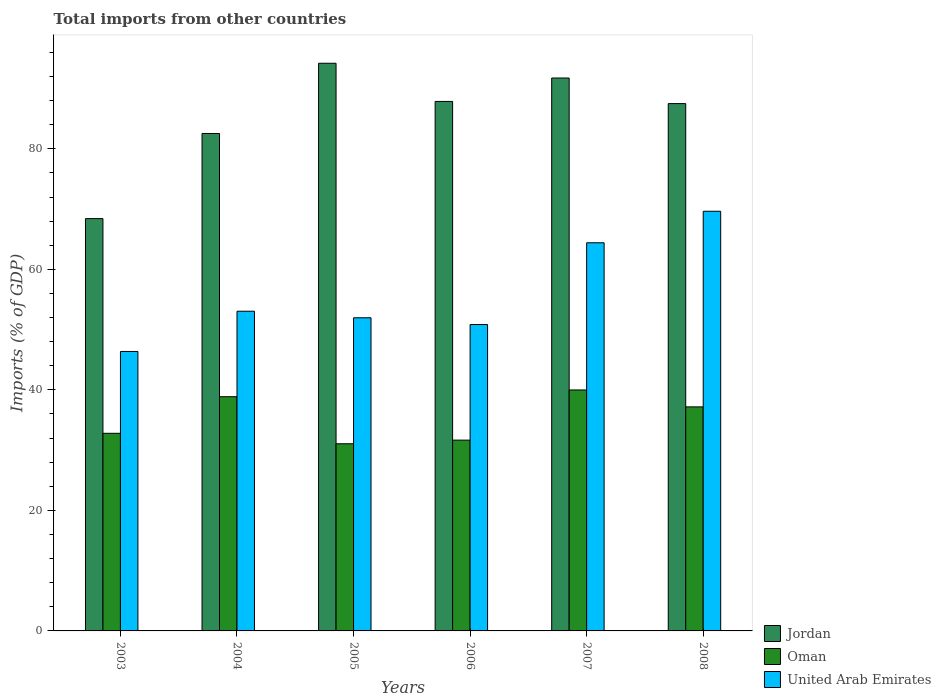How many different coloured bars are there?
Your response must be concise. 3. How many groups of bars are there?
Your answer should be compact. 6. What is the label of the 1st group of bars from the left?
Your answer should be compact. 2003. What is the total imports in Jordan in 2007?
Your answer should be compact. 91.76. Across all years, what is the maximum total imports in United Arab Emirates?
Offer a very short reply. 69.65. Across all years, what is the minimum total imports in Oman?
Provide a short and direct response. 31.06. In which year was the total imports in Jordan maximum?
Make the answer very short. 2005. What is the total total imports in Jordan in the graph?
Your answer should be compact. 512.33. What is the difference between the total imports in Oman in 2003 and that in 2007?
Offer a terse response. -7.19. What is the difference between the total imports in Jordan in 2007 and the total imports in United Arab Emirates in 2008?
Your answer should be very brief. 22.11. What is the average total imports in United Arab Emirates per year?
Provide a succinct answer. 56.05. In the year 2006, what is the difference between the total imports in Oman and total imports in Jordan?
Your answer should be very brief. -56.21. In how many years, is the total imports in United Arab Emirates greater than 16 %?
Provide a succinct answer. 6. What is the ratio of the total imports in United Arab Emirates in 2003 to that in 2006?
Keep it short and to the point. 0.91. Is the total imports in Jordan in 2006 less than that in 2007?
Give a very brief answer. Yes. What is the difference between the highest and the second highest total imports in Jordan?
Your answer should be very brief. 2.45. What is the difference between the highest and the lowest total imports in United Arab Emirates?
Your response must be concise. 23.27. In how many years, is the total imports in United Arab Emirates greater than the average total imports in United Arab Emirates taken over all years?
Your answer should be very brief. 2. Is the sum of the total imports in Oman in 2004 and 2005 greater than the maximum total imports in Jordan across all years?
Provide a short and direct response. No. What does the 2nd bar from the left in 2006 represents?
Make the answer very short. Oman. What does the 2nd bar from the right in 2006 represents?
Make the answer very short. Oman. Is it the case that in every year, the sum of the total imports in Jordan and total imports in Oman is greater than the total imports in United Arab Emirates?
Your answer should be very brief. Yes. How many bars are there?
Provide a short and direct response. 18. Are all the bars in the graph horizontal?
Your response must be concise. No. Are the values on the major ticks of Y-axis written in scientific E-notation?
Provide a short and direct response. No. Where does the legend appear in the graph?
Keep it short and to the point. Bottom right. How many legend labels are there?
Provide a short and direct response. 3. How are the legend labels stacked?
Offer a very short reply. Vertical. What is the title of the graph?
Your response must be concise. Total imports from other countries. What is the label or title of the X-axis?
Give a very brief answer. Years. What is the label or title of the Y-axis?
Your answer should be very brief. Imports (% of GDP). What is the Imports (% of GDP) in Jordan in 2003?
Your answer should be compact. 68.43. What is the Imports (% of GDP) of Oman in 2003?
Offer a terse response. 32.8. What is the Imports (% of GDP) in United Arab Emirates in 2003?
Offer a terse response. 46.38. What is the Imports (% of GDP) in Jordan in 2004?
Ensure brevity in your answer.  82.55. What is the Imports (% of GDP) of Oman in 2004?
Your answer should be very brief. 38.87. What is the Imports (% of GDP) in United Arab Emirates in 2004?
Your answer should be very brief. 53.05. What is the Imports (% of GDP) of Jordan in 2005?
Make the answer very short. 94.21. What is the Imports (% of GDP) of Oman in 2005?
Provide a short and direct response. 31.06. What is the Imports (% of GDP) of United Arab Emirates in 2005?
Offer a terse response. 51.97. What is the Imports (% of GDP) in Jordan in 2006?
Offer a terse response. 87.87. What is the Imports (% of GDP) of Oman in 2006?
Your answer should be very brief. 31.66. What is the Imports (% of GDP) of United Arab Emirates in 2006?
Offer a terse response. 50.85. What is the Imports (% of GDP) in Jordan in 2007?
Your response must be concise. 91.76. What is the Imports (% of GDP) in Oman in 2007?
Keep it short and to the point. 39.99. What is the Imports (% of GDP) of United Arab Emirates in 2007?
Offer a terse response. 64.41. What is the Imports (% of GDP) in Jordan in 2008?
Make the answer very short. 87.51. What is the Imports (% of GDP) of Oman in 2008?
Offer a very short reply. 37.18. What is the Imports (% of GDP) of United Arab Emirates in 2008?
Ensure brevity in your answer.  69.65. Across all years, what is the maximum Imports (% of GDP) of Jordan?
Your answer should be very brief. 94.21. Across all years, what is the maximum Imports (% of GDP) of Oman?
Offer a very short reply. 39.99. Across all years, what is the maximum Imports (% of GDP) in United Arab Emirates?
Provide a succinct answer. 69.65. Across all years, what is the minimum Imports (% of GDP) of Jordan?
Keep it short and to the point. 68.43. Across all years, what is the minimum Imports (% of GDP) in Oman?
Provide a short and direct response. 31.06. Across all years, what is the minimum Imports (% of GDP) of United Arab Emirates?
Ensure brevity in your answer.  46.38. What is the total Imports (% of GDP) in Jordan in the graph?
Your answer should be very brief. 512.33. What is the total Imports (% of GDP) of Oman in the graph?
Keep it short and to the point. 211.56. What is the total Imports (% of GDP) of United Arab Emirates in the graph?
Give a very brief answer. 336.3. What is the difference between the Imports (% of GDP) in Jordan in 2003 and that in 2004?
Make the answer very short. -14.13. What is the difference between the Imports (% of GDP) in Oman in 2003 and that in 2004?
Provide a succinct answer. -6.07. What is the difference between the Imports (% of GDP) in United Arab Emirates in 2003 and that in 2004?
Ensure brevity in your answer.  -6.68. What is the difference between the Imports (% of GDP) in Jordan in 2003 and that in 2005?
Your response must be concise. -25.78. What is the difference between the Imports (% of GDP) of Oman in 2003 and that in 2005?
Your response must be concise. 1.74. What is the difference between the Imports (% of GDP) of United Arab Emirates in 2003 and that in 2005?
Give a very brief answer. -5.59. What is the difference between the Imports (% of GDP) of Jordan in 2003 and that in 2006?
Offer a terse response. -19.45. What is the difference between the Imports (% of GDP) in Oman in 2003 and that in 2006?
Keep it short and to the point. 1.13. What is the difference between the Imports (% of GDP) of United Arab Emirates in 2003 and that in 2006?
Make the answer very short. -4.47. What is the difference between the Imports (% of GDP) in Jordan in 2003 and that in 2007?
Keep it short and to the point. -23.33. What is the difference between the Imports (% of GDP) in Oman in 2003 and that in 2007?
Ensure brevity in your answer.  -7.19. What is the difference between the Imports (% of GDP) in United Arab Emirates in 2003 and that in 2007?
Ensure brevity in your answer.  -18.04. What is the difference between the Imports (% of GDP) in Jordan in 2003 and that in 2008?
Ensure brevity in your answer.  -19.09. What is the difference between the Imports (% of GDP) of Oman in 2003 and that in 2008?
Ensure brevity in your answer.  -4.39. What is the difference between the Imports (% of GDP) in United Arab Emirates in 2003 and that in 2008?
Provide a short and direct response. -23.27. What is the difference between the Imports (% of GDP) of Jordan in 2004 and that in 2005?
Your response must be concise. -11.65. What is the difference between the Imports (% of GDP) in Oman in 2004 and that in 2005?
Your answer should be compact. 7.81. What is the difference between the Imports (% of GDP) in United Arab Emirates in 2004 and that in 2005?
Your response must be concise. 1.09. What is the difference between the Imports (% of GDP) of Jordan in 2004 and that in 2006?
Your answer should be compact. -5.32. What is the difference between the Imports (% of GDP) of Oman in 2004 and that in 2006?
Provide a short and direct response. 7.21. What is the difference between the Imports (% of GDP) in United Arab Emirates in 2004 and that in 2006?
Offer a terse response. 2.21. What is the difference between the Imports (% of GDP) in Jordan in 2004 and that in 2007?
Your response must be concise. -9.21. What is the difference between the Imports (% of GDP) of Oman in 2004 and that in 2007?
Your answer should be compact. -1.12. What is the difference between the Imports (% of GDP) of United Arab Emirates in 2004 and that in 2007?
Provide a short and direct response. -11.36. What is the difference between the Imports (% of GDP) in Jordan in 2004 and that in 2008?
Your answer should be very brief. -4.96. What is the difference between the Imports (% of GDP) of Oman in 2004 and that in 2008?
Your answer should be very brief. 1.69. What is the difference between the Imports (% of GDP) of United Arab Emirates in 2004 and that in 2008?
Give a very brief answer. -16.59. What is the difference between the Imports (% of GDP) of Jordan in 2005 and that in 2006?
Keep it short and to the point. 6.33. What is the difference between the Imports (% of GDP) in Oman in 2005 and that in 2006?
Offer a terse response. -0.6. What is the difference between the Imports (% of GDP) in United Arab Emirates in 2005 and that in 2006?
Offer a very short reply. 1.12. What is the difference between the Imports (% of GDP) of Jordan in 2005 and that in 2007?
Provide a short and direct response. 2.45. What is the difference between the Imports (% of GDP) in Oman in 2005 and that in 2007?
Your answer should be compact. -8.93. What is the difference between the Imports (% of GDP) in United Arab Emirates in 2005 and that in 2007?
Keep it short and to the point. -12.45. What is the difference between the Imports (% of GDP) of Jordan in 2005 and that in 2008?
Ensure brevity in your answer.  6.7. What is the difference between the Imports (% of GDP) of Oman in 2005 and that in 2008?
Make the answer very short. -6.12. What is the difference between the Imports (% of GDP) in United Arab Emirates in 2005 and that in 2008?
Your answer should be very brief. -17.68. What is the difference between the Imports (% of GDP) in Jordan in 2006 and that in 2007?
Give a very brief answer. -3.89. What is the difference between the Imports (% of GDP) in Oman in 2006 and that in 2007?
Provide a short and direct response. -8.33. What is the difference between the Imports (% of GDP) of United Arab Emirates in 2006 and that in 2007?
Make the answer very short. -13.57. What is the difference between the Imports (% of GDP) of Jordan in 2006 and that in 2008?
Your answer should be compact. 0.36. What is the difference between the Imports (% of GDP) of Oman in 2006 and that in 2008?
Offer a very short reply. -5.52. What is the difference between the Imports (% of GDP) of United Arab Emirates in 2006 and that in 2008?
Provide a short and direct response. -18.8. What is the difference between the Imports (% of GDP) in Jordan in 2007 and that in 2008?
Make the answer very short. 4.25. What is the difference between the Imports (% of GDP) of Oman in 2007 and that in 2008?
Your answer should be compact. 2.81. What is the difference between the Imports (% of GDP) in United Arab Emirates in 2007 and that in 2008?
Your answer should be very brief. -5.23. What is the difference between the Imports (% of GDP) in Jordan in 2003 and the Imports (% of GDP) in Oman in 2004?
Provide a succinct answer. 29.56. What is the difference between the Imports (% of GDP) in Jordan in 2003 and the Imports (% of GDP) in United Arab Emirates in 2004?
Provide a short and direct response. 15.37. What is the difference between the Imports (% of GDP) in Oman in 2003 and the Imports (% of GDP) in United Arab Emirates in 2004?
Make the answer very short. -20.26. What is the difference between the Imports (% of GDP) in Jordan in 2003 and the Imports (% of GDP) in Oman in 2005?
Offer a very short reply. 37.37. What is the difference between the Imports (% of GDP) of Jordan in 2003 and the Imports (% of GDP) of United Arab Emirates in 2005?
Provide a succinct answer. 16.46. What is the difference between the Imports (% of GDP) of Oman in 2003 and the Imports (% of GDP) of United Arab Emirates in 2005?
Ensure brevity in your answer.  -19.17. What is the difference between the Imports (% of GDP) of Jordan in 2003 and the Imports (% of GDP) of Oman in 2006?
Ensure brevity in your answer.  36.76. What is the difference between the Imports (% of GDP) of Jordan in 2003 and the Imports (% of GDP) of United Arab Emirates in 2006?
Provide a short and direct response. 17.58. What is the difference between the Imports (% of GDP) in Oman in 2003 and the Imports (% of GDP) in United Arab Emirates in 2006?
Your answer should be compact. -18.05. What is the difference between the Imports (% of GDP) of Jordan in 2003 and the Imports (% of GDP) of Oman in 2007?
Provide a short and direct response. 28.44. What is the difference between the Imports (% of GDP) in Jordan in 2003 and the Imports (% of GDP) in United Arab Emirates in 2007?
Provide a short and direct response. 4.01. What is the difference between the Imports (% of GDP) of Oman in 2003 and the Imports (% of GDP) of United Arab Emirates in 2007?
Give a very brief answer. -31.62. What is the difference between the Imports (% of GDP) in Jordan in 2003 and the Imports (% of GDP) in Oman in 2008?
Provide a succinct answer. 31.25. What is the difference between the Imports (% of GDP) of Jordan in 2003 and the Imports (% of GDP) of United Arab Emirates in 2008?
Make the answer very short. -1.22. What is the difference between the Imports (% of GDP) of Oman in 2003 and the Imports (% of GDP) of United Arab Emirates in 2008?
Make the answer very short. -36.85. What is the difference between the Imports (% of GDP) in Jordan in 2004 and the Imports (% of GDP) in Oman in 2005?
Give a very brief answer. 51.49. What is the difference between the Imports (% of GDP) of Jordan in 2004 and the Imports (% of GDP) of United Arab Emirates in 2005?
Provide a short and direct response. 30.59. What is the difference between the Imports (% of GDP) in Oman in 2004 and the Imports (% of GDP) in United Arab Emirates in 2005?
Make the answer very short. -13.1. What is the difference between the Imports (% of GDP) in Jordan in 2004 and the Imports (% of GDP) in Oman in 2006?
Provide a short and direct response. 50.89. What is the difference between the Imports (% of GDP) of Jordan in 2004 and the Imports (% of GDP) of United Arab Emirates in 2006?
Keep it short and to the point. 31.71. What is the difference between the Imports (% of GDP) in Oman in 2004 and the Imports (% of GDP) in United Arab Emirates in 2006?
Provide a short and direct response. -11.98. What is the difference between the Imports (% of GDP) in Jordan in 2004 and the Imports (% of GDP) in Oman in 2007?
Give a very brief answer. 42.56. What is the difference between the Imports (% of GDP) of Jordan in 2004 and the Imports (% of GDP) of United Arab Emirates in 2007?
Offer a very short reply. 18.14. What is the difference between the Imports (% of GDP) of Oman in 2004 and the Imports (% of GDP) of United Arab Emirates in 2007?
Give a very brief answer. -25.54. What is the difference between the Imports (% of GDP) of Jordan in 2004 and the Imports (% of GDP) of Oman in 2008?
Your answer should be compact. 45.37. What is the difference between the Imports (% of GDP) in Jordan in 2004 and the Imports (% of GDP) in United Arab Emirates in 2008?
Ensure brevity in your answer.  12.91. What is the difference between the Imports (% of GDP) in Oman in 2004 and the Imports (% of GDP) in United Arab Emirates in 2008?
Ensure brevity in your answer.  -30.78. What is the difference between the Imports (% of GDP) in Jordan in 2005 and the Imports (% of GDP) in Oman in 2006?
Offer a very short reply. 62.54. What is the difference between the Imports (% of GDP) of Jordan in 2005 and the Imports (% of GDP) of United Arab Emirates in 2006?
Offer a very short reply. 43.36. What is the difference between the Imports (% of GDP) of Oman in 2005 and the Imports (% of GDP) of United Arab Emirates in 2006?
Provide a short and direct response. -19.79. What is the difference between the Imports (% of GDP) of Jordan in 2005 and the Imports (% of GDP) of Oman in 2007?
Keep it short and to the point. 54.22. What is the difference between the Imports (% of GDP) in Jordan in 2005 and the Imports (% of GDP) in United Arab Emirates in 2007?
Give a very brief answer. 29.79. What is the difference between the Imports (% of GDP) in Oman in 2005 and the Imports (% of GDP) in United Arab Emirates in 2007?
Your answer should be very brief. -33.35. What is the difference between the Imports (% of GDP) of Jordan in 2005 and the Imports (% of GDP) of Oman in 2008?
Offer a terse response. 57.03. What is the difference between the Imports (% of GDP) of Jordan in 2005 and the Imports (% of GDP) of United Arab Emirates in 2008?
Give a very brief answer. 24.56. What is the difference between the Imports (% of GDP) of Oman in 2005 and the Imports (% of GDP) of United Arab Emirates in 2008?
Your answer should be very brief. -38.59. What is the difference between the Imports (% of GDP) in Jordan in 2006 and the Imports (% of GDP) in Oman in 2007?
Your answer should be compact. 47.88. What is the difference between the Imports (% of GDP) of Jordan in 2006 and the Imports (% of GDP) of United Arab Emirates in 2007?
Your response must be concise. 23.46. What is the difference between the Imports (% of GDP) of Oman in 2006 and the Imports (% of GDP) of United Arab Emirates in 2007?
Keep it short and to the point. -32.75. What is the difference between the Imports (% of GDP) of Jordan in 2006 and the Imports (% of GDP) of Oman in 2008?
Ensure brevity in your answer.  50.69. What is the difference between the Imports (% of GDP) in Jordan in 2006 and the Imports (% of GDP) in United Arab Emirates in 2008?
Your answer should be compact. 18.23. What is the difference between the Imports (% of GDP) in Oman in 2006 and the Imports (% of GDP) in United Arab Emirates in 2008?
Your answer should be compact. -37.98. What is the difference between the Imports (% of GDP) of Jordan in 2007 and the Imports (% of GDP) of Oman in 2008?
Provide a succinct answer. 54.58. What is the difference between the Imports (% of GDP) in Jordan in 2007 and the Imports (% of GDP) in United Arab Emirates in 2008?
Provide a short and direct response. 22.11. What is the difference between the Imports (% of GDP) in Oman in 2007 and the Imports (% of GDP) in United Arab Emirates in 2008?
Offer a terse response. -29.66. What is the average Imports (% of GDP) in Jordan per year?
Your response must be concise. 85.39. What is the average Imports (% of GDP) in Oman per year?
Make the answer very short. 35.26. What is the average Imports (% of GDP) of United Arab Emirates per year?
Make the answer very short. 56.05. In the year 2003, what is the difference between the Imports (% of GDP) of Jordan and Imports (% of GDP) of Oman?
Your response must be concise. 35.63. In the year 2003, what is the difference between the Imports (% of GDP) of Jordan and Imports (% of GDP) of United Arab Emirates?
Keep it short and to the point. 22.05. In the year 2003, what is the difference between the Imports (% of GDP) in Oman and Imports (% of GDP) in United Arab Emirates?
Offer a terse response. -13.58. In the year 2004, what is the difference between the Imports (% of GDP) in Jordan and Imports (% of GDP) in Oman?
Make the answer very short. 43.68. In the year 2004, what is the difference between the Imports (% of GDP) of Jordan and Imports (% of GDP) of United Arab Emirates?
Make the answer very short. 29.5. In the year 2004, what is the difference between the Imports (% of GDP) in Oman and Imports (% of GDP) in United Arab Emirates?
Offer a very short reply. -14.19. In the year 2005, what is the difference between the Imports (% of GDP) in Jordan and Imports (% of GDP) in Oman?
Offer a terse response. 63.15. In the year 2005, what is the difference between the Imports (% of GDP) of Jordan and Imports (% of GDP) of United Arab Emirates?
Your response must be concise. 42.24. In the year 2005, what is the difference between the Imports (% of GDP) of Oman and Imports (% of GDP) of United Arab Emirates?
Offer a terse response. -20.91. In the year 2006, what is the difference between the Imports (% of GDP) in Jordan and Imports (% of GDP) in Oman?
Provide a succinct answer. 56.21. In the year 2006, what is the difference between the Imports (% of GDP) in Jordan and Imports (% of GDP) in United Arab Emirates?
Your answer should be compact. 37.03. In the year 2006, what is the difference between the Imports (% of GDP) in Oman and Imports (% of GDP) in United Arab Emirates?
Offer a terse response. -19.18. In the year 2007, what is the difference between the Imports (% of GDP) of Jordan and Imports (% of GDP) of Oman?
Make the answer very short. 51.77. In the year 2007, what is the difference between the Imports (% of GDP) of Jordan and Imports (% of GDP) of United Arab Emirates?
Ensure brevity in your answer.  27.34. In the year 2007, what is the difference between the Imports (% of GDP) in Oman and Imports (% of GDP) in United Arab Emirates?
Offer a very short reply. -24.42. In the year 2008, what is the difference between the Imports (% of GDP) in Jordan and Imports (% of GDP) in Oman?
Offer a terse response. 50.33. In the year 2008, what is the difference between the Imports (% of GDP) in Jordan and Imports (% of GDP) in United Arab Emirates?
Ensure brevity in your answer.  17.87. In the year 2008, what is the difference between the Imports (% of GDP) of Oman and Imports (% of GDP) of United Arab Emirates?
Your response must be concise. -32.47. What is the ratio of the Imports (% of GDP) in Jordan in 2003 to that in 2004?
Ensure brevity in your answer.  0.83. What is the ratio of the Imports (% of GDP) in Oman in 2003 to that in 2004?
Keep it short and to the point. 0.84. What is the ratio of the Imports (% of GDP) in United Arab Emirates in 2003 to that in 2004?
Give a very brief answer. 0.87. What is the ratio of the Imports (% of GDP) in Jordan in 2003 to that in 2005?
Offer a terse response. 0.73. What is the ratio of the Imports (% of GDP) in Oman in 2003 to that in 2005?
Your answer should be very brief. 1.06. What is the ratio of the Imports (% of GDP) in United Arab Emirates in 2003 to that in 2005?
Give a very brief answer. 0.89. What is the ratio of the Imports (% of GDP) of Jordan in 2003 to that in 2006?
Keep it short and to the point. 0.78. What is the ratio of the Imports (% of GDP) of Oman in 2003 to that in 2006?
Keep it short and to the point. 1.04. What is the ratio of the Imports (% of GDP) of United Arab Emirates in 2003 to that in 2006?
Offer a terse response. 0.91. What is the ratio of the Imports (% of GDP) in Jordan in 2003 to that in 2007?
Your answer should be very brief. 0.75. What is the ratio of the Imports (% of GDP) of Oman in 2003 to that in 2007?
Ensure brevity in your answer.  0.82. What is the ratio of the Imports (% of GDP) in United Arab Emirates in 2003 to that in 2007?
Give a very brief answer. 0.72. What is the ratio of the Imports (% of GDP) of Jordan in 2003 to that in 2008?
Your answer should be very brief. 0.78. What is the ratio of the Imports (% of GDP) of Oman in 2003 to that in 2008?
Provide a succinct answer. 0.88. What is the ratio of the Imports (% of GDP) of United Arab Emirates in 2003 to that in 2008?
Offer a very short reply. 0.67. What is the ratio of the Imports (% of GDP) of Jordan in 2004 to that in 2005?
Your answer should be compact. 0.88. What is the ratio of the Imports (% of GDP) in Oman in 2004 to that in 2005?
Make the answer very short. 1.25. What is the ratio of the Imports (% of GDP) in United Arab Emirates in 2004 to that in 2005?
Offer a very short reply. 1.02. What is the ratio of the Imports (% of GDP) in Jordan in 2004 to that in 2006?
Ensure brevity in your answer.  0.94. What is the ratio of the Imports (% of GDP) of Oman in 2004 to that in 2006?
Provide a short and direct response. 1.23. What is the ratio of the Imports (% of GDP) in United Arab Emirates in 2004 to that in 2006?
Keep it short and to the point. 1.04. What is the ratio of the Imports (% of GDP) in Jordan in 2004 to that in 2007?
Ensure brevity in your answer.  0.9. What is the ratio of the Imports (% of GDP) of United Arab Emirates in 2004 to that in 2007?
Offer a terse response. 0.82. What is the ratio of the Imports (% of GDP) in Jordan in 2004 to that in 2008?
Your response must be concise. 0.94. What is the ratio of the Imports (% of GDP) in Oman in 2004 to that in 2008?
Your response must be concise. 1.05. What is the ratio of the Imports (% of GDP) in United Arab Emirates in 2004 to that in 2008?
Your answer should be compact. 0.76. What is the ratio of the Imports (% of GDP) in Jordan in 2005 to that in 2006?
Offer a very short reply. 1.07. What is the ratio of the Imports (% of GDP) of Oman in 2005 to that in 2006?
Your answer should be very brief. 0.98. What is the ratio of the Imports (% of GDP) in United Arab Emirates in 2005 to that in 2006?
Offer a terse response. 1.02. What is the ratio of the Imports (% of GDP) in Jordan in 2005 to that in 2007?
Your response must be concise. 1.03. What is the ratio of the Imports (% of GDP) of Oman in 2005 to that in 2007?
Offer a terse response. 0.78. What is the ratio of the Imports (% of GDP) in United Arab Emirates in 2005 to that in 2007?
Your response must be concise. 0.81. What is the ratio of the Imports (% of GDP) in Jordan in 2005 to that in 2008?
Offer a terse response. 1.08. What is the ratio of the Imports (% of GDP) of Oman in 2005 to that in 2008?
Make the answer very short. 0.84. What is the ratio of the Imports (% of GDP) in United Arab Emirates in 2005 to that in 2008?
Offer a very short reply. 0.75. What is the ratio of the Imports (% of GDP) of Jordan in 2006 to that in 2007?
Your answer should be compact. 0.96. What is the ratio of the Imports (% of GDP) of Oman in 2006 to that in 2007?
Ensure brevity in your answer.  0.79. What is the ratio of the Imports (% of GDP) in United Arab Emirates in 2006 to that in 2007?
Keep it short and to the point. 0.79. What is the ratio of the Imports (% of GDP) in Jordan in 2006 to that in 2008?
Give a very brief answer. 1. What is the ratio of the Imports (% of GDP) of Oman in 2006 to that in 2008?
Offer a terse response. 0.85. What is the ratio of the Imports (% of GDP) of United Arab Emirates in 2006 to that in 2008?
Your answer should be very brief. 0.73. What is the ratio of the Imports (% of GDP) of Jordan in 2007 to that in 2008?
Your answer should be very brief. 1.05. What is the ratio of the Imports (% of GDP) in Oman in 2007 to that in 2008?
Give a very brief answer. 1.08. What is the ratio of the Imports (% of GDP) of United Arab Emirates in 2007 to that in 2008?
Give a very brief answer. 0.92. What is the difference between the highest and the second highest Imports (% of GDP) in Jordan?
Give a very brief answer. 2.45. What is the difference between the highest and the second highest Imports (% of GDP) in Oman?
Provide a succinct answer. 1.12. What is the difference between the highest and the second highest Imports (% of GDP) of United Arab Emirates?
Ensure brevity in your answer.  5.23. What is the difference between the highest and the lowest Imports (% of GDP) of Jordan?
Offer a very short reply. 25.78. What is the difference between the highest and the lowest Imports (% of GDP) of Oman?
Ensure brevity in your answer.  8.93. What is the difference between the highest and the lowest Imports (% of GDP) of United Arab Emirates?
Give a very brief answer. 23.27. 